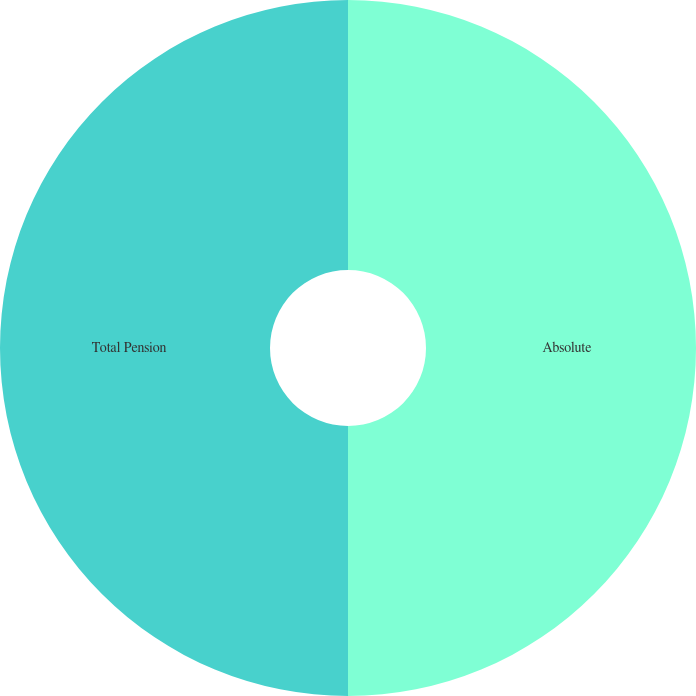Convert chart to OTSL. <chart><loc_0><loc_0><loc_500><loc_500><pie_chart><fcel>Absolute<fcel>Total Pension<nl><fcel>50.0%<fcel>50.0%<nl></chart> 